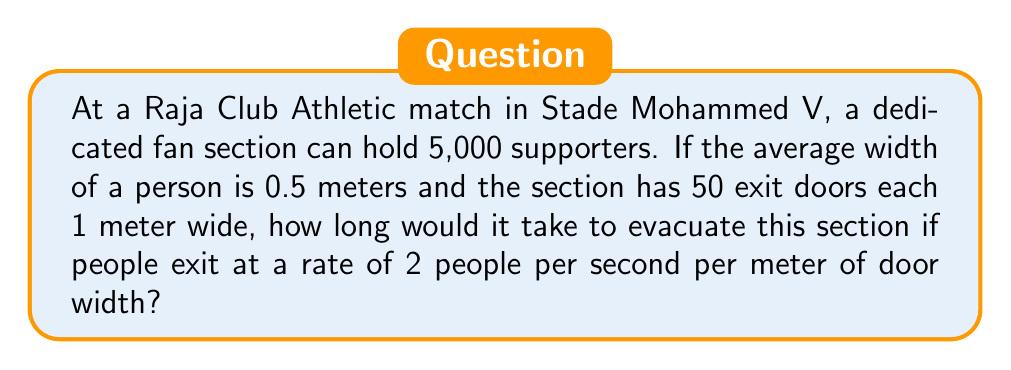Teach me how to tackle this problem. Let's approach this step-by-step:

1. Calculate the total exit width:
   Number of doors = 50
   Width per door = 1 meter
   Total exit width = $50 \times 1 = 50$ meters

2. Calculate the evacuation rate:
   Rate per meter of door width = 2 people/second
   Total evacuation rate = $50 \text{ meters} \times 2 \text{ people/second/meter} = 100$ people/second

3. Calculate the evacuation time:
   Total number of people = 5,000
   Time = Number of people / Evacuation rate
   $$T = \frac{5000 \text{ people}}{100 \text{ people/second}} = 50 \text{ seconds}$$

Therefore, it would take 50 seconds to evacuate the section under these conditions.
Answer: 50 seconds 